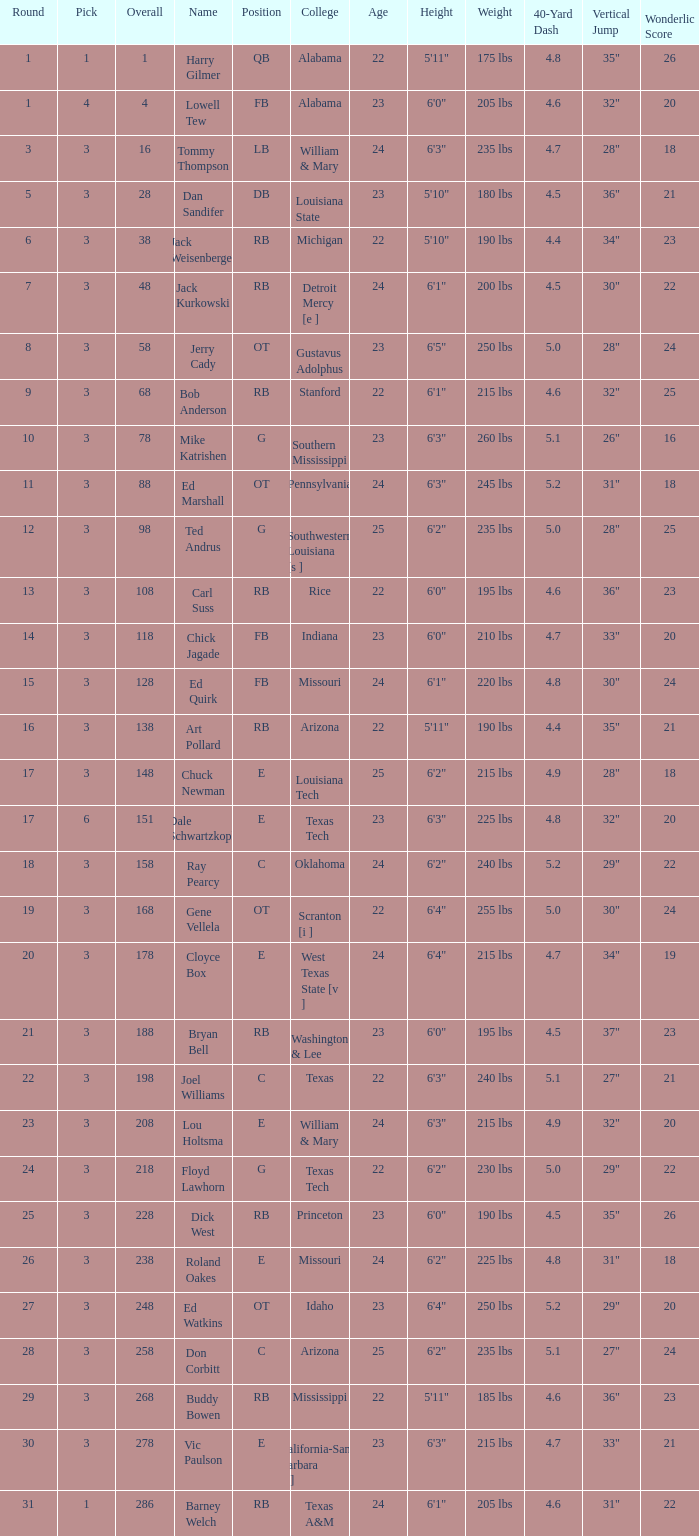How much Overall has a Name of bob anderson? 1.0. 